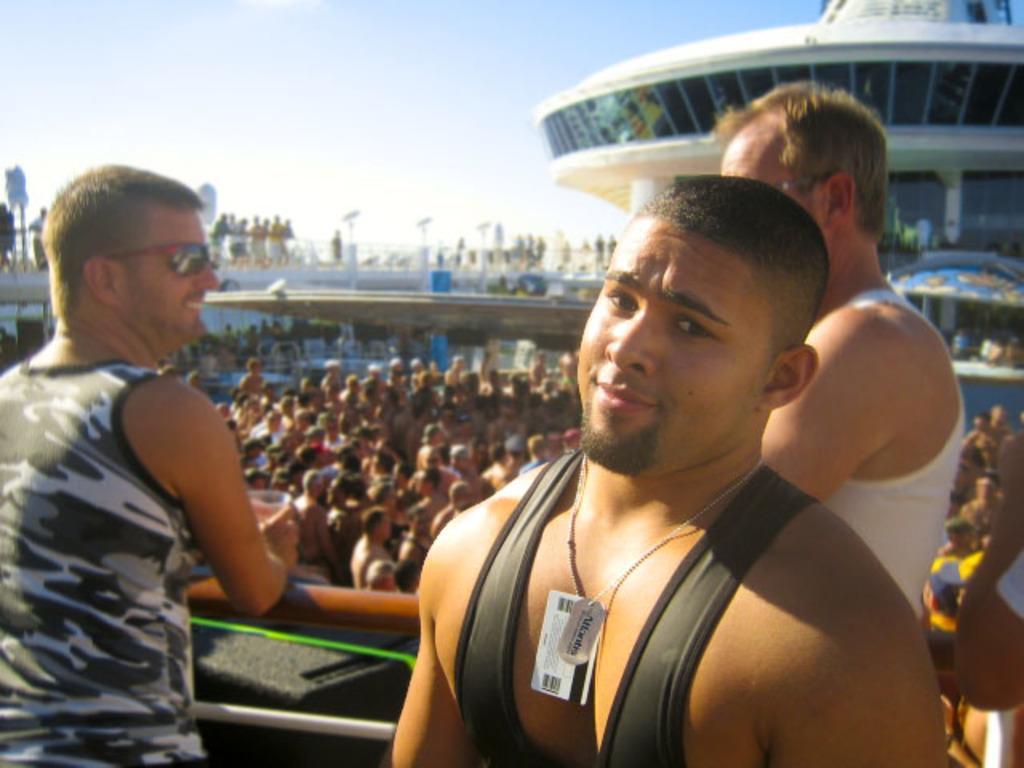Please provide a concise description of this image. There are three men standing. This looks like an iron pole. I can see group of people standing. This is the building with glass doors. I think this is the bridge. 